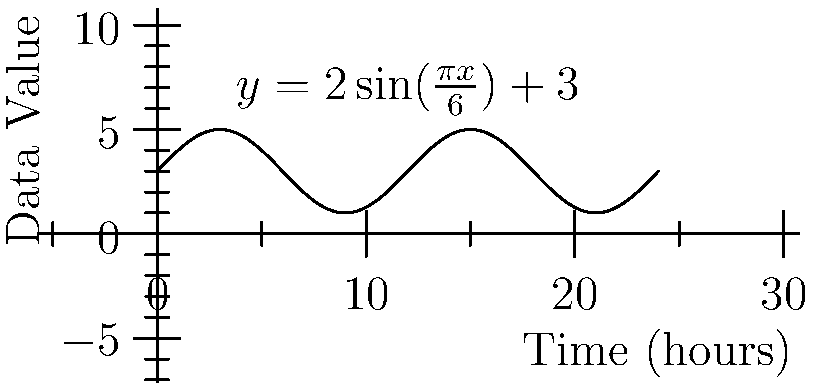In your research project, you've collected periodic data that seems to follow a sinusoidal pattern over a 24-hour cycle. After analysis, you've modeled the data using the function $y = 2\sin(\frac{\pi x}{6}) + 3$, where $x$ represents the time in hours and $y$ represents the data value. What is the period of this function in hours? To find the period of the given function, we need to follow these steps:

1) The general form of a sine function is:
   $y = A\sin(B(x - C)) + D$
   where $B = \frac{2\pi}{P}$, and $P$ is the period.

2) In our function $y = 2\sin(\frac{\pi x}{6}) + 3$, we can identify that $B = \frac{\pi}{6}$.

3) We know that $B = \frac{2\pi}{P}$, so:
   $\frac{\pi}{6} = \frac{2\pi}{P}$

4) Solving for $P$:
   $P = \frac{2\pi}{\frac{\pi}{6}} = 2\pi \cdot \frac{6}{\pi} = 12$

Therefore, the period of the function is 12 hours.
Answer: 12 hours 